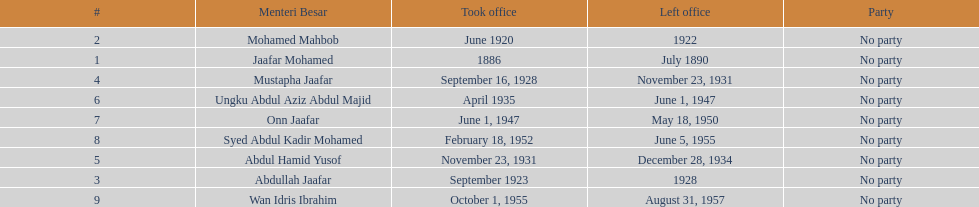How many years was jaafar mohamed in office? 4. 